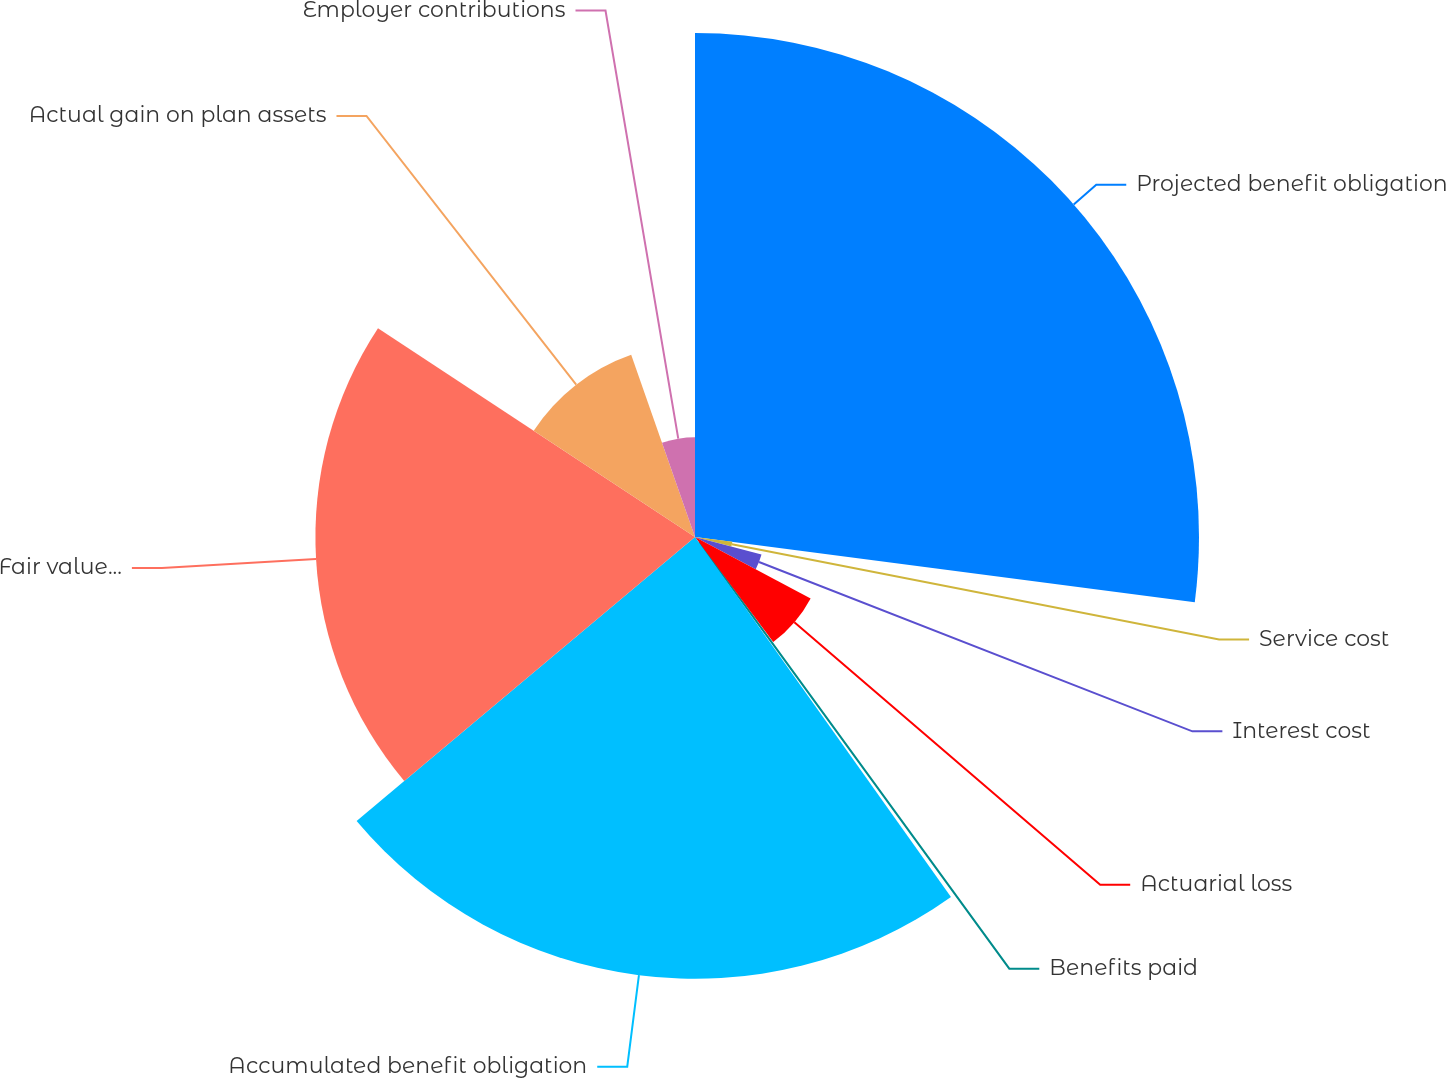Convert chart. <chart><loc_0><loc_0><loc_500><loc_500><pie_chart><fcel>Projected benefit obligation<fcel>Service cost<fcel>Interest cost<fcel>Actuarial loss<fcel>Benefits paid<fcel>Accumulated benefit obligation<fcel>Fair value of plan assets at<fcel>Actual gain on plan assets<fcel>Employer contributions<nl><fcel>27.06%<fcel>2.02%<fcel>3.69%<fcel>7.03%<fcel>0.36%<fcel>23.72%<fcel>20.38%<fcel>10.37%<fcel>5.36%<nl></chart> 